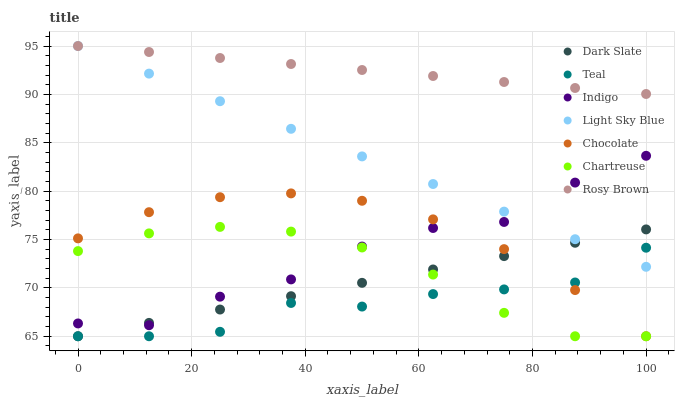Does Teal have the minimum area under the curve?
Answer yes or no. Yes. Does Rosy Brown have the maximum area under the curve?
Answer yes or no. Yes. Does Chocolate have the minimum area under the curve?
Answer yes or no. No. Does Chocolate have the maximum area under the curve?
Answer yes or no. No. Is Rosy Brown the smoothest?
Answer yes or no. Yes. Is Indigo the roughest?
Answer yes or no. Yes. Is Chocolate the smoothest?
Answer yes or no. No. Is Chocolate the roughest?
Answer yes or no. No. Does Chocolate have the lowest value?
Answer yes or no. Yes. Does Rosy Brown have the lowest value?
Answer yes or no. No. Does Light Sky Blue have the highest value?
Answer yes or no. Yes. Does Chocolate have the highest value?
Answer yes or no. No. Is Chartreuse less than Light Sky Blue?
Answer yes or no. Yes. Is Rosy Brown greater than Teal?
Answer yes or no. Yes. Does Teal intersect Chartreuse?
Answer yes or no. Yes. Is Teal less than Chartreuse?
Answer yes or no. No. Is Teal greater than Chartreuse?
Answer yes or no. No. Does Chartreuse intersect Light Sky Blue?
Answer yes or no. No. 